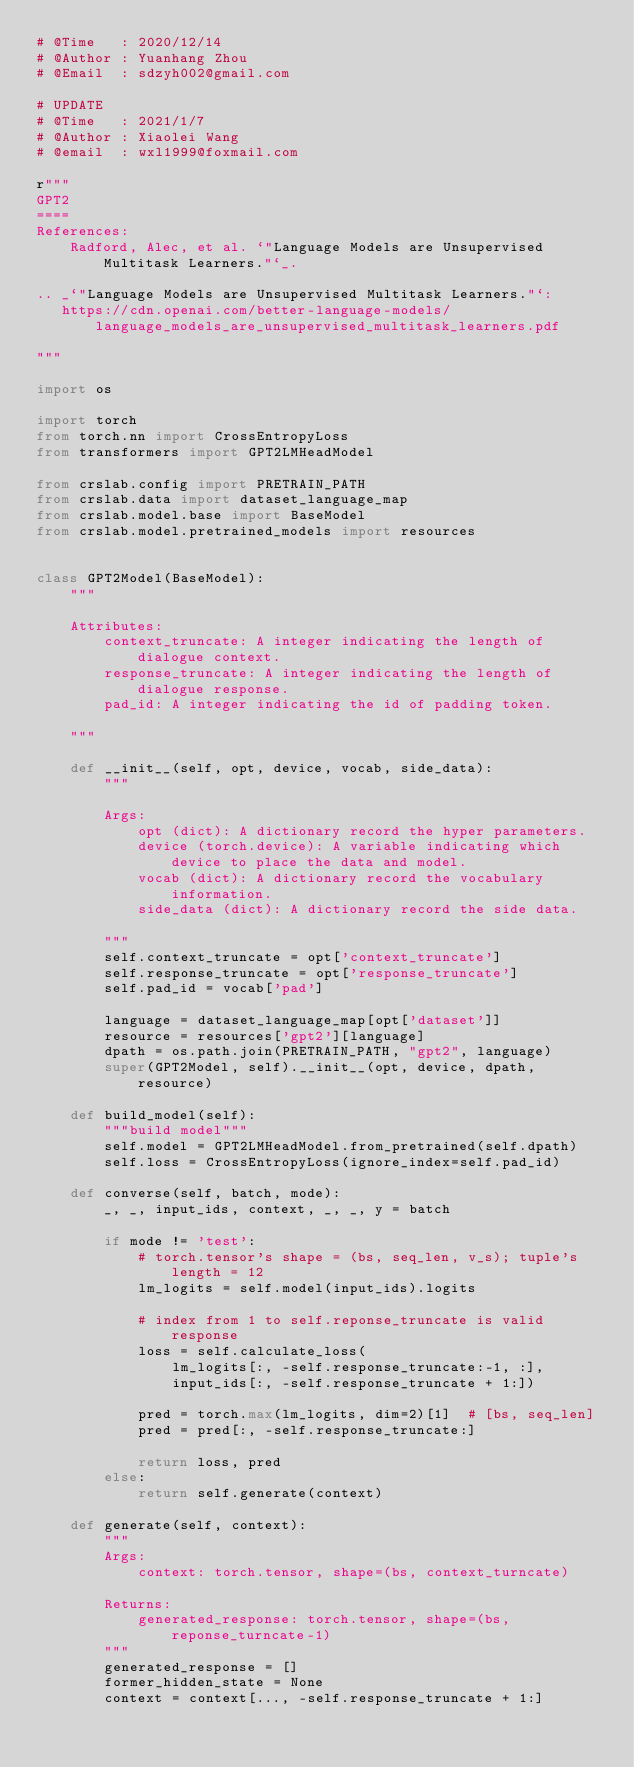Convert code to text. <code><loc_0><loc_0><loc_500><loc_500><_Python_># @Time   : 2020/12/14
# @Author : Yuanhang Zhou
# @Email  : sdzyh002@gmail.com

# UPDATE
# @Time   : 2021/1/7
# @Author : Xiaolei Wang
# @email  : wxl1999@foxmail.com

r"""
GPT2
====
References:
    Radford, Alec, et al. `"Language Models are Unsupervised Multitask Learners."`_.

.. _`"Language Models are Unsupervised Multitask Learners."`:
   https://cdn.openai.com/better-language-models/language_models_are_unsupervised_multitask_learners.pdf

"""

import os

import torch
from torch.nn import CrossEntropyLoss
from transformers import GPT2LMHeadModel

from crslab.config import PRETRAIN_PATH
from crslab.data import dataset_language_map
from crslab.model.base import BaseModel
from crslab.model.pretrained_models import resources


class GPT2Model(BaseModel):
    """
        
    Attributes:
        context_truncate: A integer indicating the length of dialogue context.
        response_truncate: A integer indicating the length of dialogue response.
        pad_id: A integer indicating the id of padding token.

    """

    def __init__(self, opt, device, vocab, side_data):
        """

        Args:
            opt (dict): A dictionary record the hyper parameters.
            device (torch.device): A variable indicating which device to place the data and model.
            vocab (dict): A dictionary record the vocabulary information.
            side_data (dict): A dictionary record the side data.

        """
        self.context_truncate = opt['context_truncate']
        self.response_truncate = opt['response_truncate']
        self.pad_id = vocab['pad']

        language = dataset_language_map[opt['dataset']]
        resource = resources['gpt2'][language]
        dpath = os.path.join(PRETRAIN_PATH, "gpt2", language)
        super(GPT2Model, self).__init__(opt, device, dpath, resource)

    def build_model(self):
        """build model"""
        self.model = GPT2LMHeadModel.from_pretrained(self.dpath)
        self.loss = CrossEntropyLoss(ignore_index=self.pad_id)

    def converse(self, batch, mode):
        _, _, input_ids, context, _, _, y = batch

        if mode != 'test':
            # torch.tensor's shape = (bs, seq_len, v_s); tuple's length = 12
            lm_logits = self.model(input_ids).logits

            # index from 1 to self.reponse_truncate is valid response
            loss = self.calculate_loss(
                lm_logits[:, -self.response_truncate:-1, :],
                input_ids[:, -self.response_truncate + 1:])

            pred = torch.max(lm_logits, dim=2)[1]  # [bs, seq_len]
            pred = pred[:, -self.response_truncate:]

            return loss, pred
        else:
            return self.generate(context)

    def generate(self, context):
        """
        Args:
            context: torch.tensor, shape=(bs, context_turncate)

        Returns:
            generated_response: torch.tensor, shape=(bs, reponse_turncate-1)
        """
        generated_response = []
        former_hidden_state = None
        context = context[..., -self.response_truncate + 1:]
</code> 